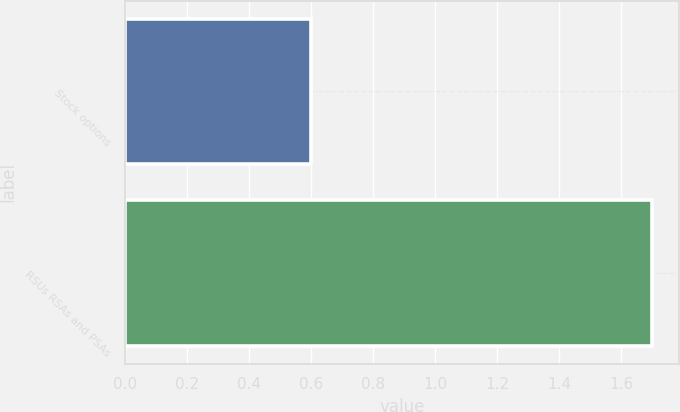Convert chart to OTSL. <chart><loc_0><loc_0><loc_500><loc_500><bar_chart><fcel>Stock options<fcel>RSUs RSAs and PSAs<nl><fcel>0.6<fcel>1.7<nl></chart> 